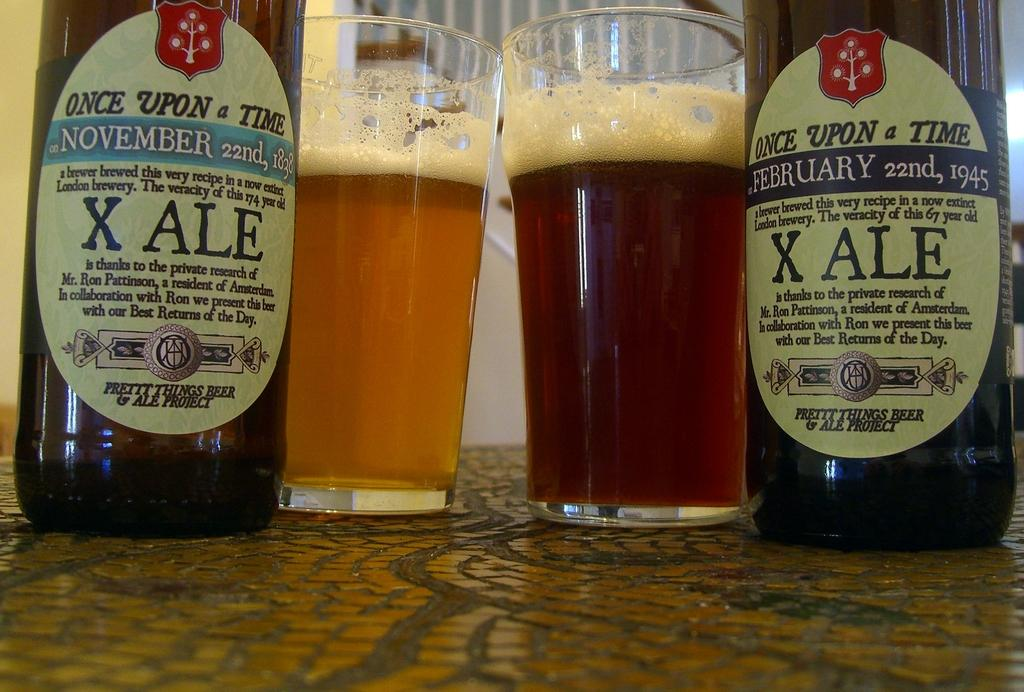Provide a one-sentence caption for the provided image. Two types of X ALE beers are shown on a table next to beers in glasses. 